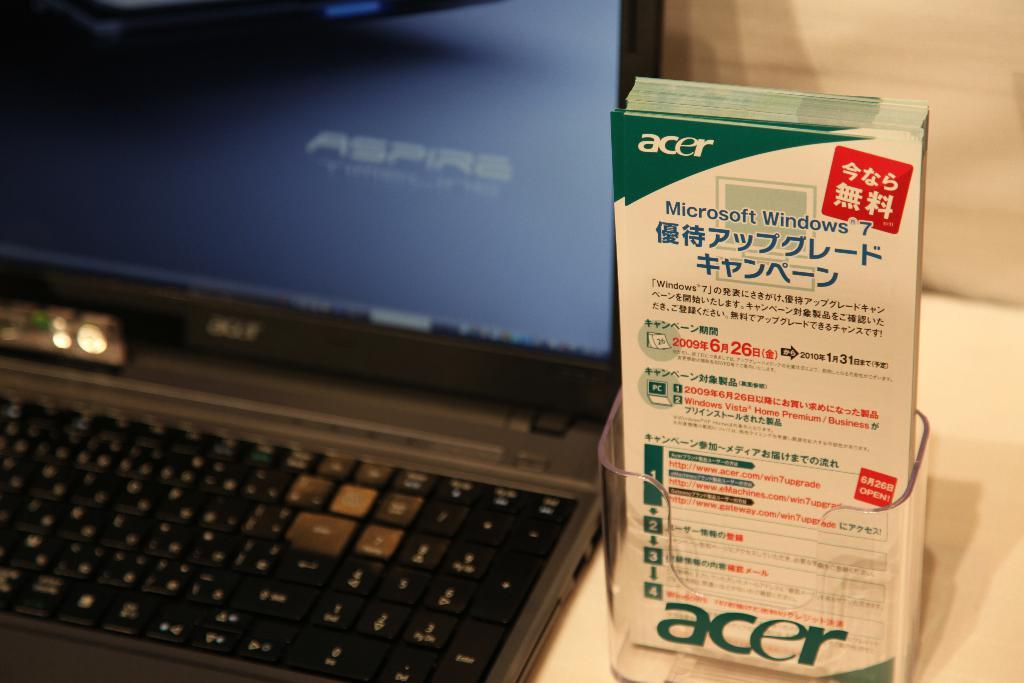Provide a one-sentence caption for the provided image. An Acer laptop sits next to some advertisement pamphlets. 